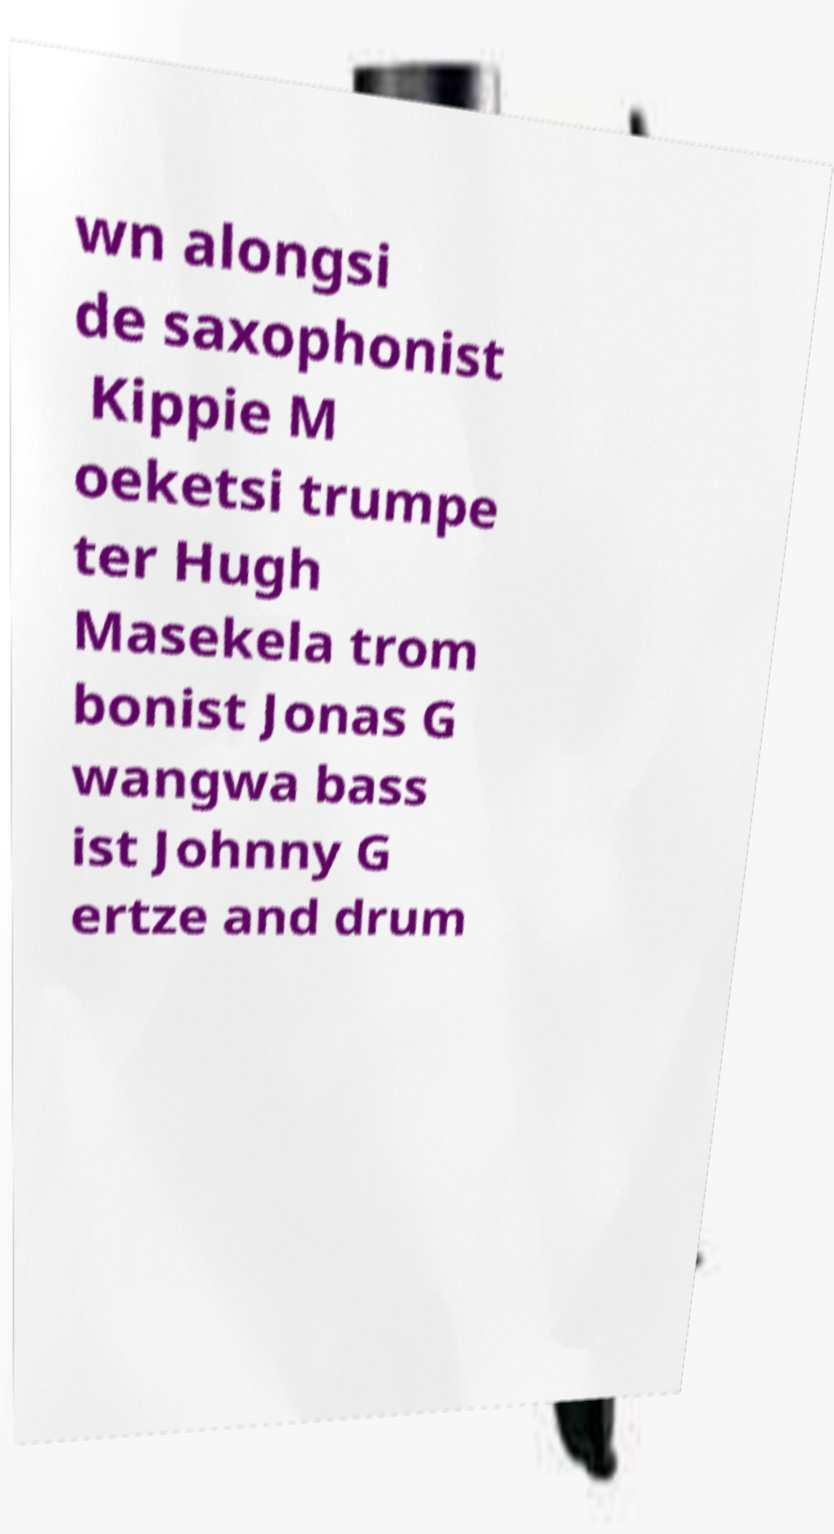There's text embedded in this image that I need extracted. Can you transcribe it verbatim? wn alongsi de saxophonist Kippie M oeketsi trumpe ter Hugh Masekela trom bonist Jonas G wangwa bass ist Johnny G ertze and drum 